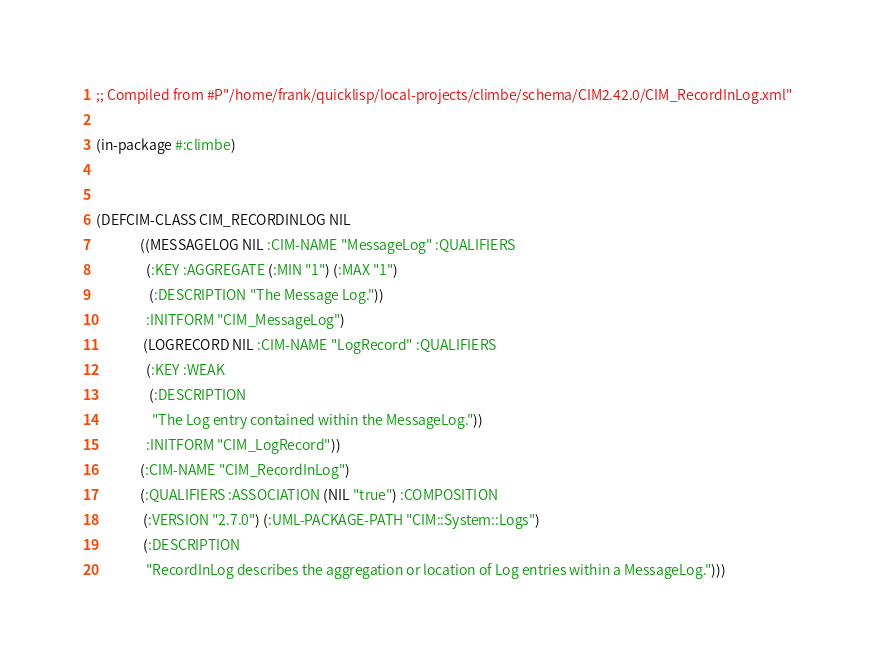Convert code to text. <code><loc_0><loc_0><loc_500><loc_500><_Lisp_>
;; Compiled from #P"/home/frank/quicklisp/local-projects/climbe/schema/CIM2.42.0/CIM_RecordInLog.xml"

(in-package #:climbe)


(DEFCIM-CLASS CIM_RECORDINLOG NIL
              ((MESSAGELOG NIL :CIM-NAME "MessageLog" :QUALIFIERS
                (:KEY :AGGREGATE (:MIN "1") (:MAX "1")
                 (:DESCRIPTION "The Message Log."))
                :INITFORM "CIM_MessageLog")
               (LOGRECORD NIL :CIM-NAME "LogRecord" :QUALIFIERS
                (:KEY :WEAK
                 (:DESCRIPTION
                  "The Log entry contained within the MessageLog."))
                :INITFORM "CIM_LogRecord"))
              (:CIM-NAME "CIM_RecordInLog")
              (:QUALIFIERS :ASSOCIATION (NIL "true") :COMPOSITION
               (:VERSION "2.7.0") (:UML-PACKAGE-PATH "CIM::System::Logs")
               (:DESCRIPTION
                "RecordInLog describes the aggregation or location of Log entries within a MessageLog.")))</code> 